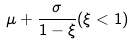Convert formula to latex. <formula><loc_0><loc_0><loc_500><loc_500>\mu + \frac { \sigma } { 1 - \xi } ( \xi < 1 )</formula> 